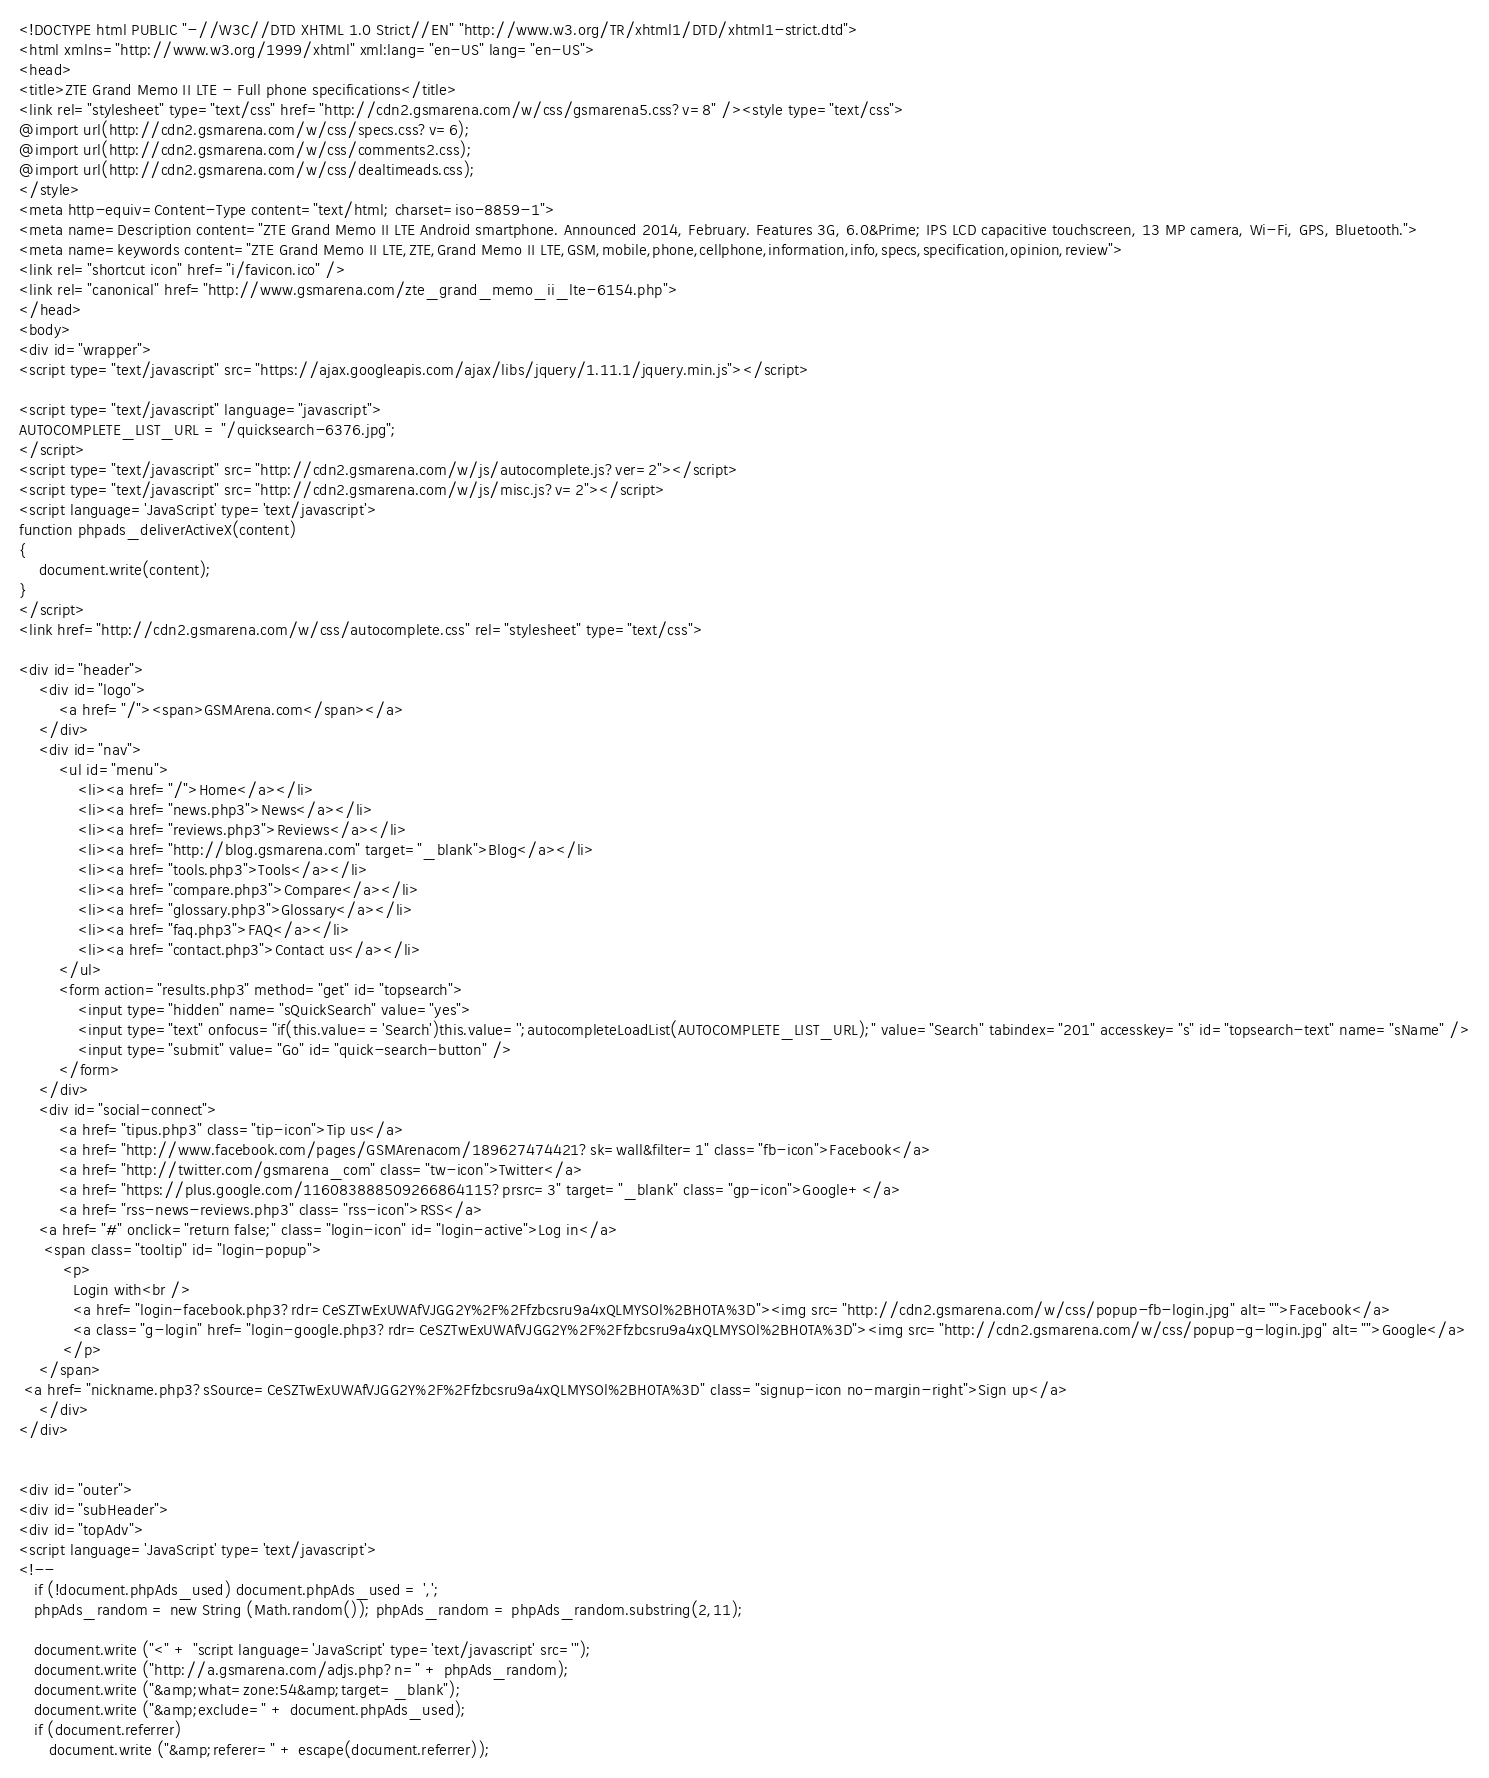<code> <loc_0><loc_0><loc_500><loc_500><_PHP_><!DOCTYPE html PUBLIC "-//W3C//DTD XHTML 1.0 Strict//EN" "http://www.w3.org/TR/xhtml1/DTD/xhtml1-strict.dtd">
<html xmlns="http://www.w3.org/1999/xhtml" xml:lang="en-US" lang="en-US">
<head>
<title>ZTE Grand Memo II LTE - Full phone specifications</title>
<link rel="stylesheet" type="text/css" href="http://cdn2.gsmarena.com/w/css/gsmarena5.css?v=8" /><style type="text/css">
@import url(http://cdn2.gsmarena.com/w/css/specs.css?v=6);
@import url(http://cdn2.gsmarena.com/w/css/comments2.css);
@import url(http://cdn2.gsmarena.com/w/css/dealtimeads.css);
</style>
<meta http-equiv=Content-Type content="text/html; charset=iso-8859-1">
<meta name=Description content="ZTE Grand Memo II LTE Android smartphone. Announced 2014, February. Features 3G, 6.0&Prime; IPS LCD capacitive touchscreen, 13 MP camera, Wi-Fi, GPS, Bluetooth.">
<meta name=keywords content="ZTE Grand Memo II LTE,ZTE,Grand Memo II LTE,GSM,mobile,phone,cellphone,information,info,specs,specification,opinion,review">
<link rel="shortcut icon" href="i/favicon.ico" />
<link rel="canonical" href="http://www.gsmarena.com/zte_grand_memo_ii_lte-6154.php">
</head>
<body>
<div id="wrapper">
<script type="text/javascript" src="https://ajax.googleapis.com/ajax/libs/jquery/1.11.1/jquery.min.js"></script>

<script type="text/javascript" language="javascript">
AUTOCOMPLETE_LIST_URL = "/quicksearch-6376.jpg";
</script>
<script type="text/javascript" src="http://cdn2.gsmarena.com/w/js/autocomplete.js?ver=2"></script>
<script type="text/javascript" src="http://cdn2.gsmarena.com/w/js/misc.js?v=2"></script>
<script language='JavaScript' type='text/javascript'>
function phpads_deliverActiveX(content)
{
	document.write(content);	
}
</script>
<link href="http://cdn2.gsmarena.com/w/css/autocomplete.css" rel="stylesheet" type="text/css">

<div id="header">
	<div id="logo">
    	<a href="/"><span>GSMArena.com</span></a>
    </div>
	<div id="nav">
    	<ul id="menu">
        	<li><a href="/">Home</a></li>
        	<li><a href="news.php3">News</a></li>
        	<li><a href="reviews.php3">Reviews</a></li>
        	<li><a href="http://blog.gsmarena.com" target="_blank">Blog</a></li>
			<li><a href="tools.php3">Tools</a></li>			
        	<li><a href="compare.php3">Compare</a></li>
        	<li><a href="glossary.php3">Glossary</a></li>
        	<li><a href="faq.php3">FAQ</a></li>
        	<li><a href="contact.php3">Contact us</a></li>
        </ul>
        <form action="results.php3" method="get" id="topsearch">
            <input type="hidden" name="sQuickSearch" value="yes">
            <input type="text" onfocus="if(this.value=='Search')this.value='';autocompleteLoadList(AUTOCOMPLETE_LIST_URL);" value="Search" tabindex="201" accesskey="s" id="topsearch-text" name="sName" />
            <input type="submit" value="Go" id="quick-search-button" />
        </form>
    </div>
    <div id="social-connect">
    	<a href="tipus.php3" class="tip-icon">Tip us</a>
    	<a href="http://www.facebook.com/pages/GSMArenacom/189627474421?sk=wall&filter=1" class="fb-icon">Facebook</a>
        <a href="http://twitter.com/gsmarena_com" class="tw-icon">Twitter</a>
		<a href="https://plus.google.com/116083888509266864115?prsrc=3" target="_blank" class="gp-icon">Google+</a>
        <a href="rss-news-reviews.php3" class="rss-icon">RSS</a>
	<a href="#" onclick="return false;" class="login-icon" id="login-active">Log in</a>
     <span class="tooltip" id="login-popup">
         <p>
           Login with<br />
           <a href="login-facebook.php3?rdr=CeSZTwExUWAfVJGG2Y%2F%2Ffzbcsru9a4xQLMYSOl%2BH0TA%3D"><img src="http://cdn2.gsmarena.com/w/css/popup-fb-login.jpg" alt="">Facebook</a>
           <a class="g-login" href="login-google.php3?rdr=CeSZTwExUWAfVJGG2Y%2F%2Ffzbcsru9a4xQLMYSOl%2BH0TA%3D"><img src="http://cdn2.gsmarena.com/w/css/popup-g-login.jpg" alt="">Google</a>
         </p>
    </span>	
 <a href="nickname.php3?sSource=CeSZTwExUWAfVJGG2Y%2F%2Ffzbcsru9a4xQLMYSOl%2BH0TA%3D" class="signup-icon no-margin-right">Sign up</a>			
    </div>	
</div>
		

<div id="outer">
<div id="subHeader">
<div id="topAdv">
<script language='JavaScript' type='text/javascript'>
<!--
   if (!document.phpAds_used) document.phpAds_used = ',';
   phpAds_random = new String (Math.random()); phpAds_random = phpAds_random.substring(2,11);
   
   document.write ("<" + "script language='JavaScript' type='text/javascript' src='");
   document.write ("http://a.gsmarena.com/adjs.php?n=" + phpAds_random);
   document.write ("&amp;what=zone:54&amp;target=_blank");
   document.write ("&amp;exclude=" + document.phpAds_used);
   if (document.referrer)
      document.write ("&amp;referer=" + escape(document.referrer));</code> 